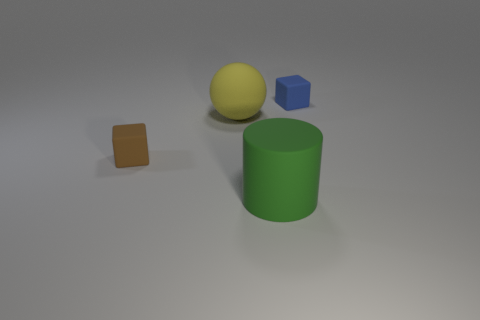Subtract all blue cubes. How many cubes are left? 1 Add 3 small blue rubber objects. How many objects exist? 7 Subtract all cylinders. How many objects are left? 3 Subtract all purple cubes. How many brown spheres are left? 0 Subtract all gray balls. Subtract all green cubes. How many balls are left? 1 Subtract all large gray shiny blocks. Subtract all small matte blocks. How many objects are left? 2 Add 1 blue cubes. How many blue cubes are left? 2 Add 3 small gray shiny objects. How many small gray shiny objects exist? 3 Subtract 0 brown spheres. How many objects are left? 4 